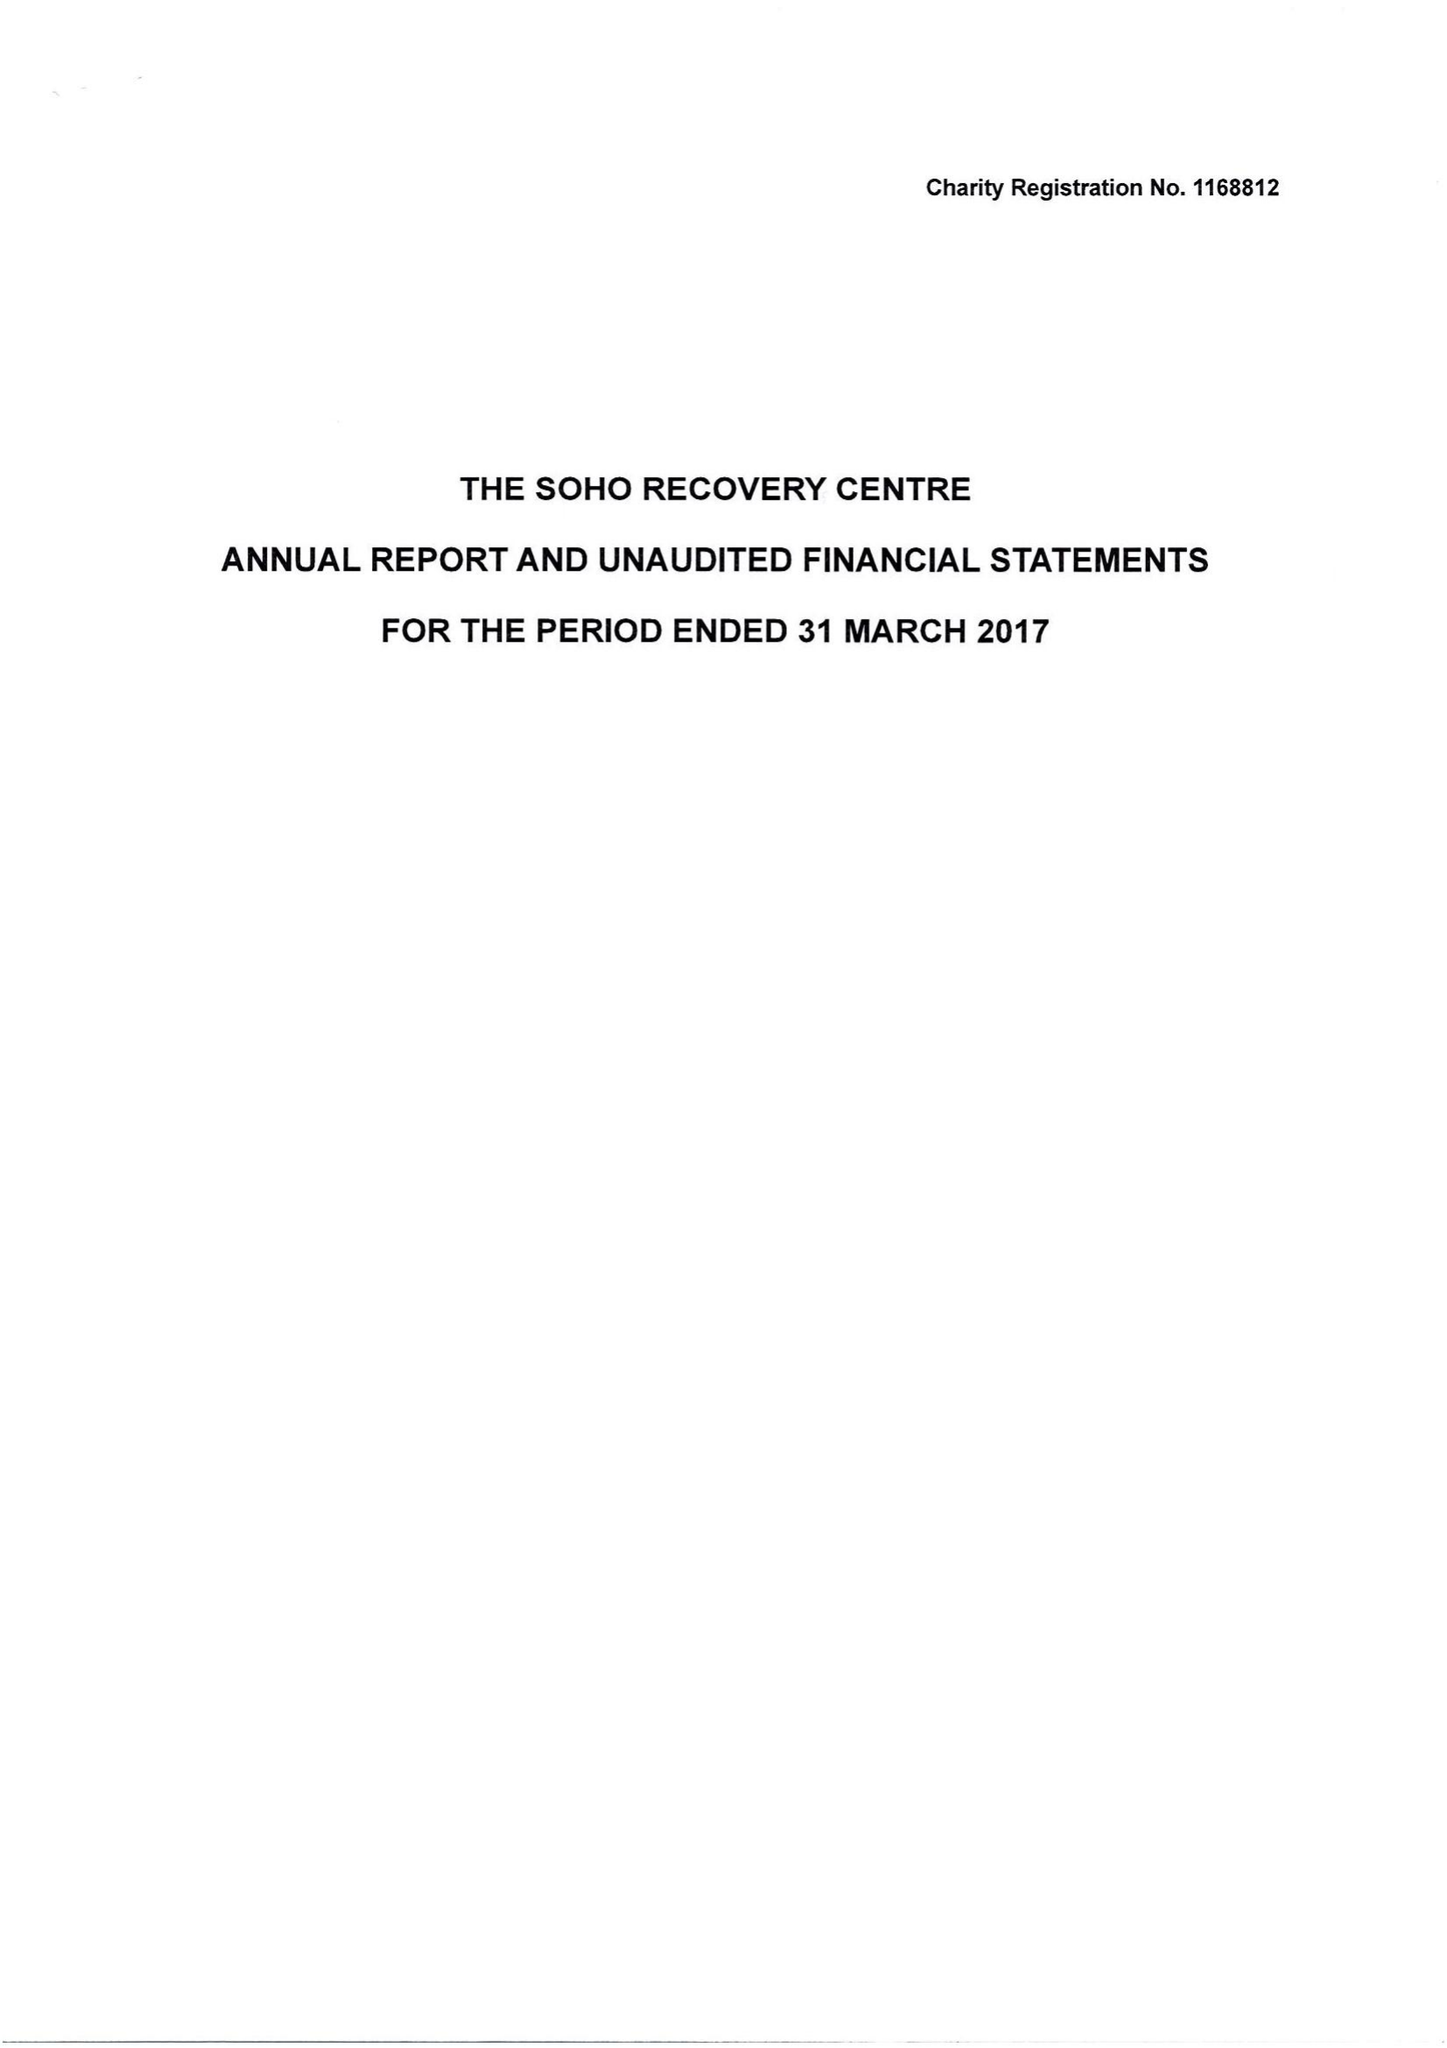What is the value for the spending_annually_in_british_pounds?
Answer the question using a single word or phrase. 3866.00 